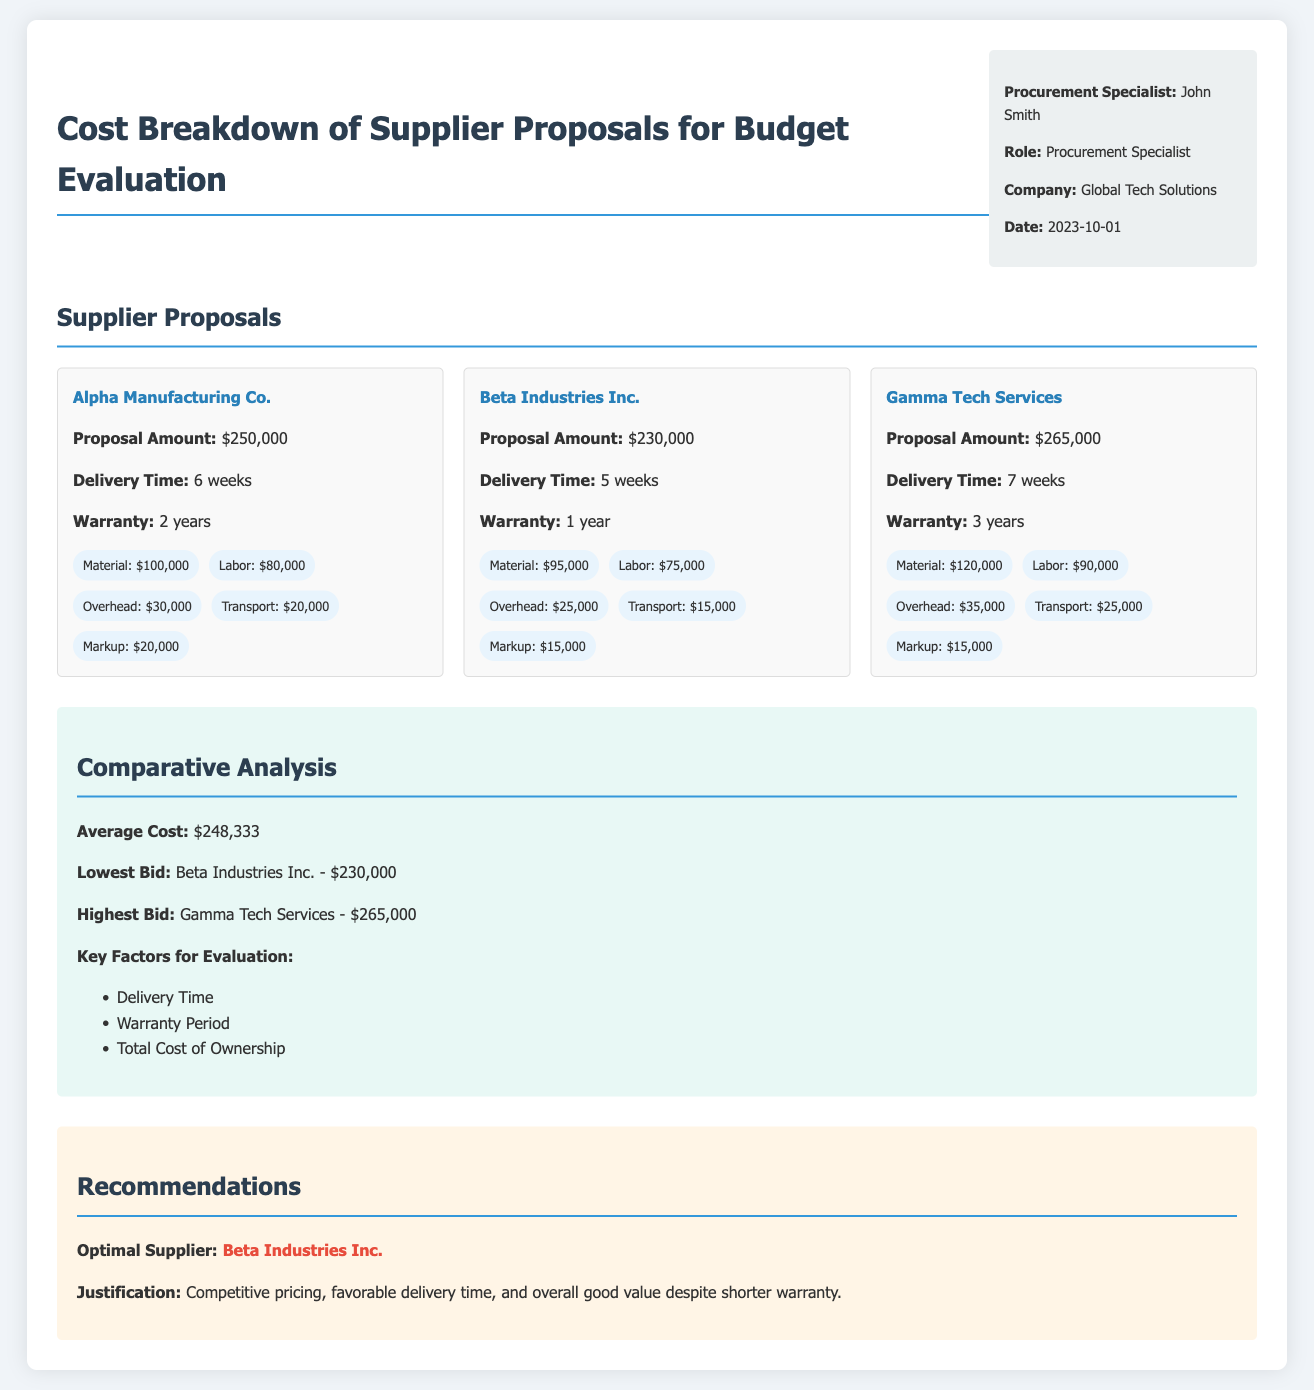What is the proposal amount from Alpha Manufacturing Co.? The proposal amount is listed in the supplier details, which is $250,000.
Answer: $250,000 Who is the procurement specialist for this evaluation? The name of the procurement specialist is mentioned in the document, which is John Smith.
Answer: John Smith What is the delivery time for Beta Industries Inc.? The delivery time is specified in the supplier proposal details, which is 5 weeks.
Answer: 5 weeks What is the average cost of the proposals? The average cost is calculated and mentioned in the comparative analysis section, which is $248,333.
Answer: $248,333 Which supplier has the highest bid? The highest bid is noted in the comparative analysis, which is Gamma Tech Services - $265,000.
Answer: Gamma Tech Services - $265,000 What warranty period does Gamma Tech Services offer? The warranty is specified in the supplier details, which is 3 years.
Answer: 3 years What key factor is listed for evaluation in the document? The document lists several factors for evaluation, and one of them is Delivery Time.
Answer: Delivery Time Who is the optimal supplier recommended in the document? The optimal supplier is mentioned in the recommendations section as Beta Industries Inc.
Answer: Beta Industries Inc What is the lowest bid amount? The lowest bid is indicated in the comparative analysis, which is $230,000.
Answer: $230,000 